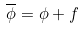<formula> <loc_0><loc_0><loc_500><loc_500>\overline { \phi } = \phi + f</formula> 